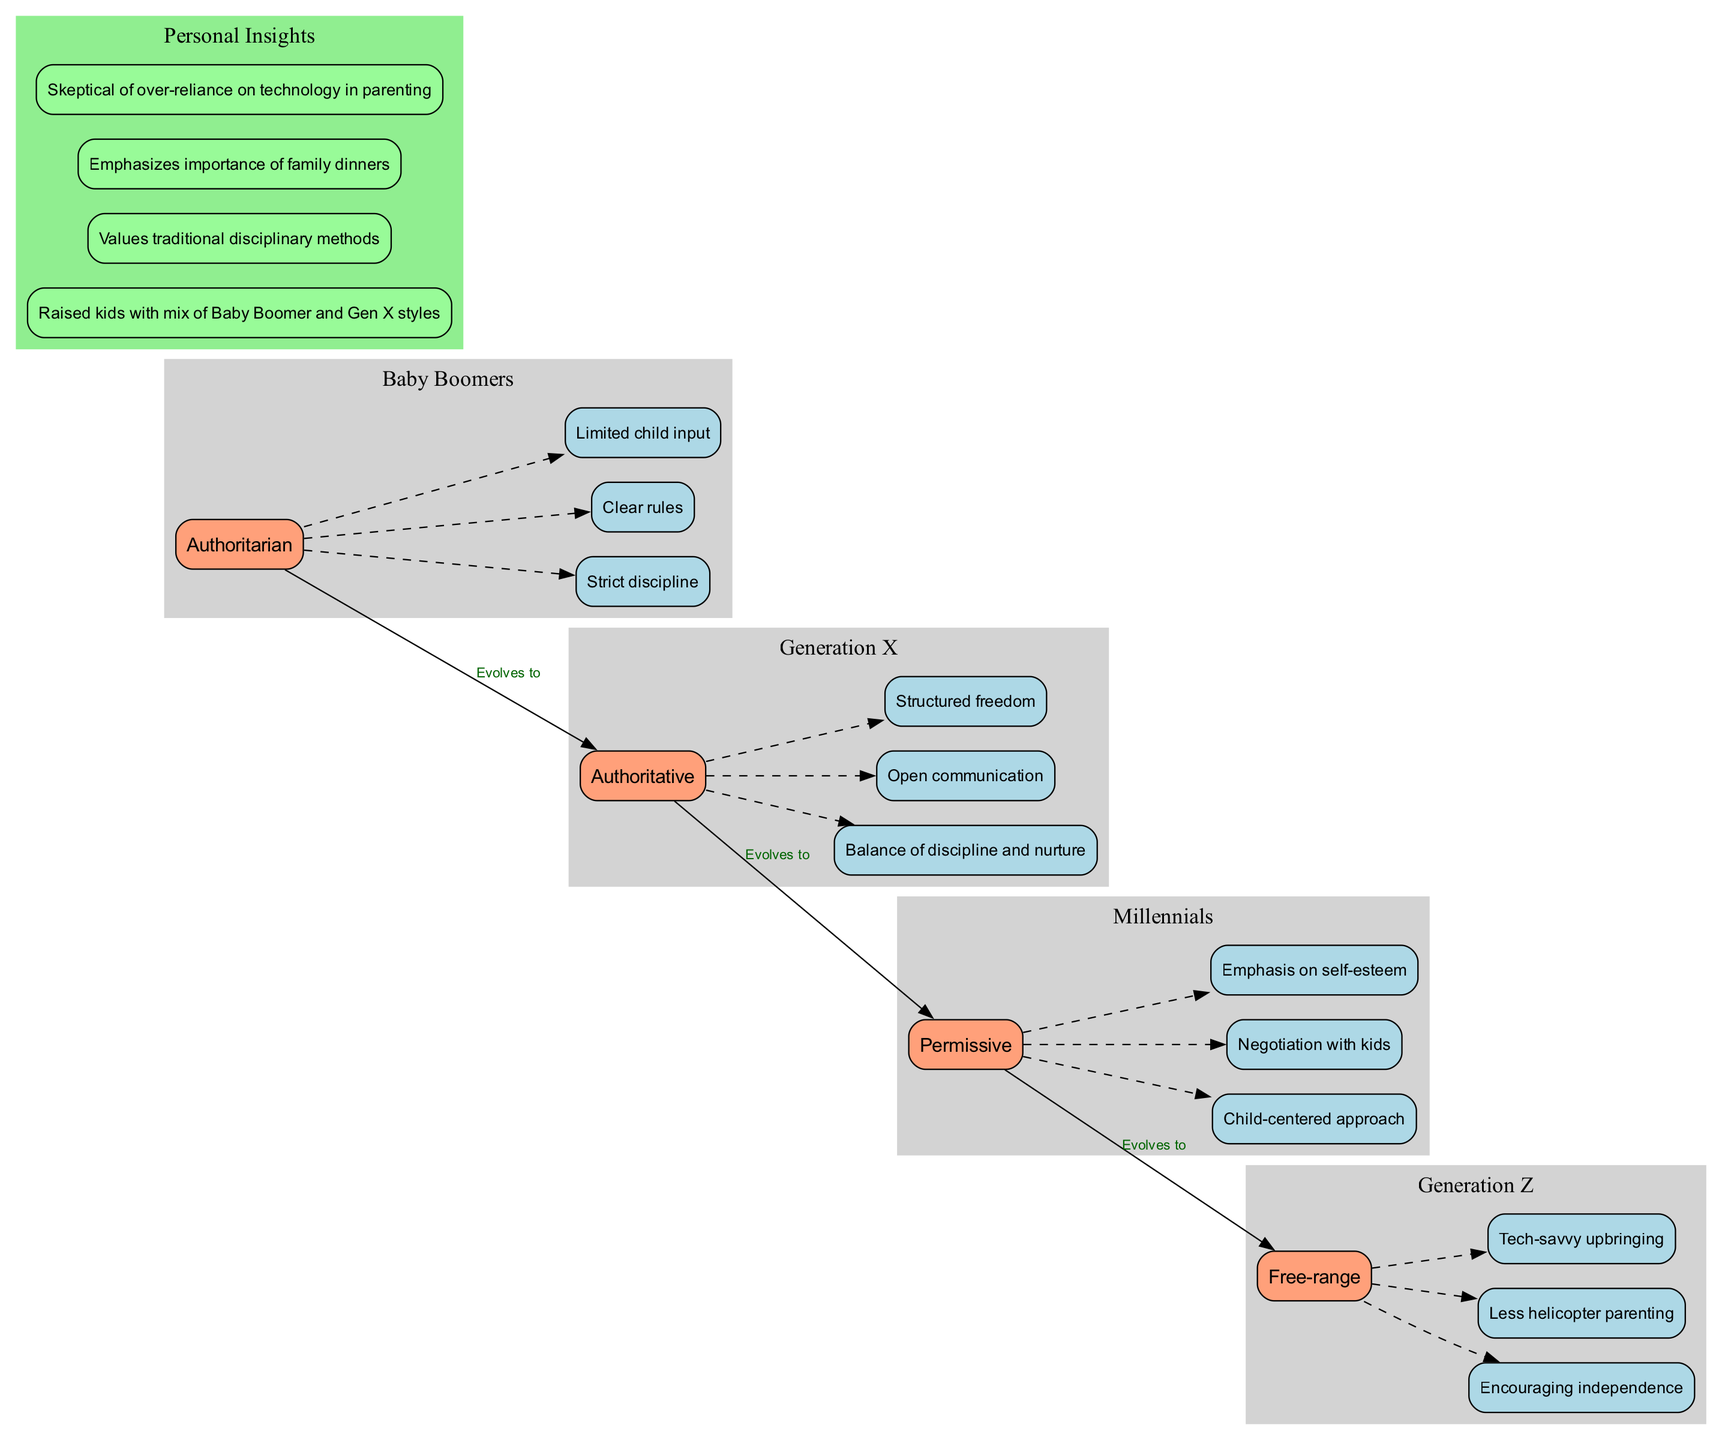What is the parenting style of Generation X? The diagram illustrates that Generation X has an "Authoritative" parenting style. This is evident from the node labeled as Generation X's style, which clearly states the parenting style in the summary.
Answer: Authoritative How many generations are represented in the diagram? The diagram includes four generations: Baby Boomers, Generation X, Millennials, and Generation Z. The count of the generational nodes confirms this total.
Answer: Four Which generation utilizes a child-centered approach in their parenting style? The Millennials are associated with a child-centered approach, as indicated by the characteristics listed under their parenting style node in the diagram.
Answer: Millennials What characteristic is associated with Generation Z’s parenting style? The data under the Generation Z node shows "Encouraging independence," which is one of their key characteristics reflecting their free-range parenting style.
Answer: Encouraging independence Which parenting style evolves from Authoritarian to Authoritative? The flow of edges indicates that the parenting style transitions from Authoritarian of the Baby Boomers to Authoritative of Generation X. This relationship is explicitly shown by the edge labeled "Evolves to."
Answer: Authoritarian What does the "Personal Insights" cluster emphasize regarding the author's parenting approach? The Personal Insights cluster includes a node that emphasizes that the author values traditional disciplinary methods. This suggests a preference rooted in earlier parenting practices.
Answer: Traditional disciplinary methods How does Generation Z differ from Baby Boomers in their approach to technology in parenting? The characteristics for Generation Z explicitly state a "Tech-savvy upbringing" with less helicopter parenting, contrasting the Baby Boomers' more traditional approach without such technology emphasis.
Answer: Tech-savvy upbringing What edge connects Millennials and Generation Z in the diagram? The edge labeled "Evolves to" connects the parenting style of Millennials to Generation Z, indicating a transition in style across these generations.
Answer: Evolves to What is a key reason Millennials are characterized as permissive parents? The characteristics of Millennials describe "Negotiation with kids," indicating a hallmark of permissive parenting styles, which prioritizes flexibility and child input.
Answer: Negotiation with kids 